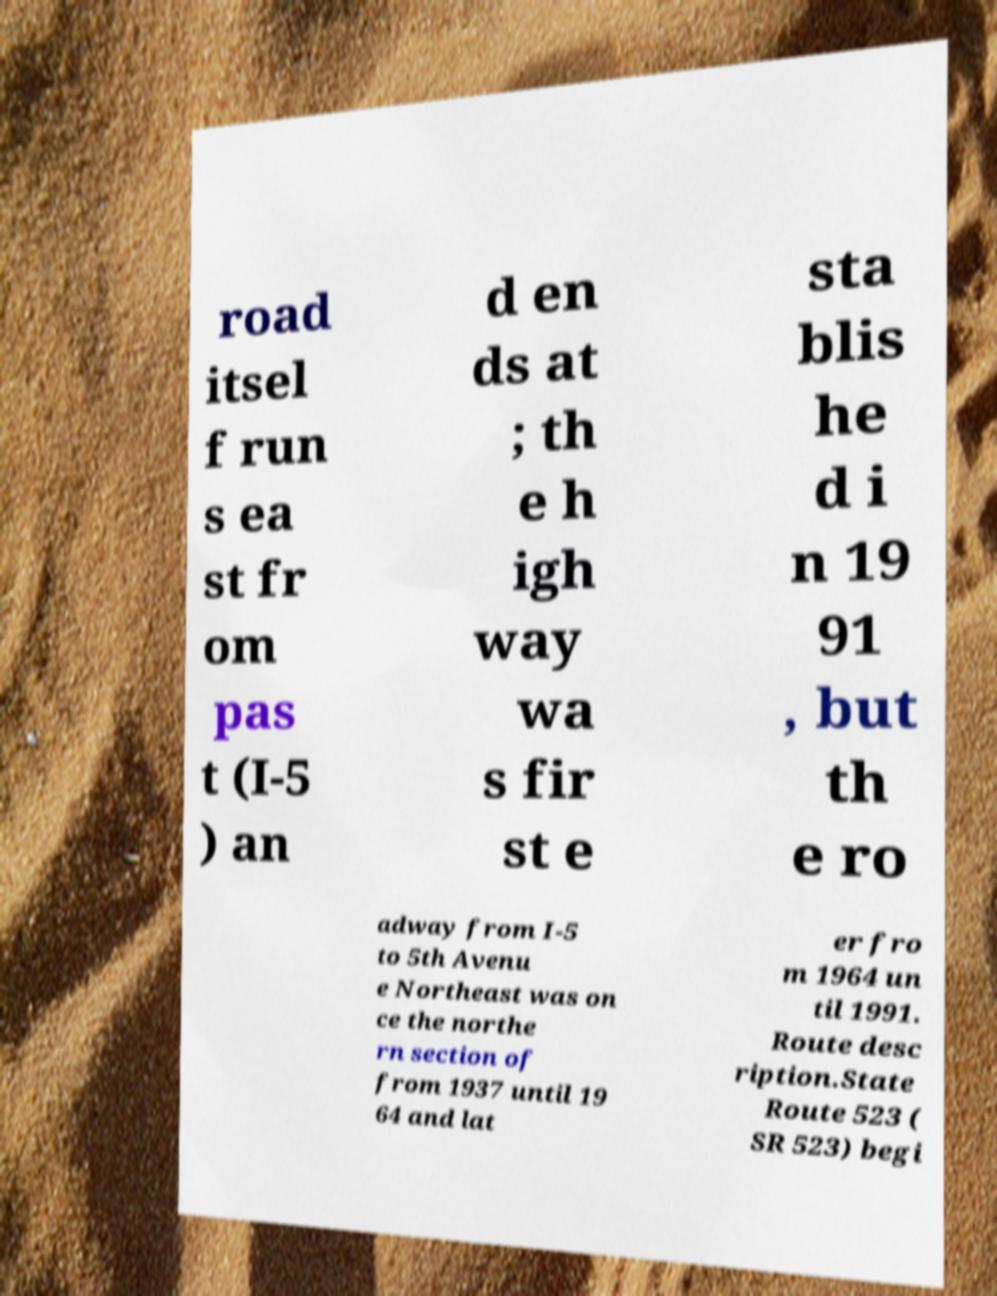I need the written content from this picture converted into text. Can you do that? road itsel f run s ea st fr om pas t (I-5 ) an d en ds at ; th e h igh way wa s fir st e sta blis he d i n 19 91 , but th e ro adway from I-5 to 5th Avenu e Northeast was on ce the northe rn section of from 1937 until 19 64 and lat er fro m 1964 un til 1991. Route desc ription.State Route 523 ( SR 523) begi 